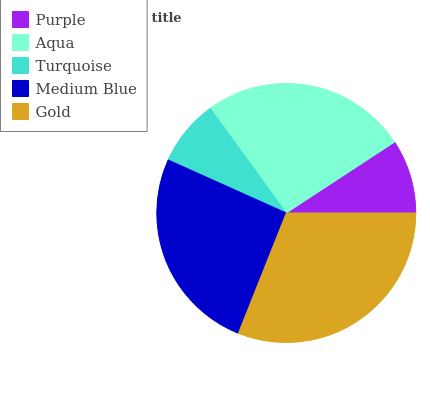Is Turquoise the minimum?
Answer yes or no. Yes. Is Gold the maximum?
Answer yes or no. Yes. Is Aqua the minimum?
Answer yes or no. No. Is Aqua the maximum?
Answer yes or no. No. Is Aqua greater than Purple?
Answer yes or no. Yes. Is Purple less than Aqua?
Answer yes or no. Yes. Is Purple greater than Aqua?
Answer yes or no. No. Is Aqua less than Purple?
Answer yes or no. No. Is Medium Blue the high median?
Answer yes or no. Yes. Is Medium Blue the low median?
Answer yes or no. Yes. Is Aqua the high median?
Answer yes or no. No. Is Aqua the low median?
Answer yes or no. No. 